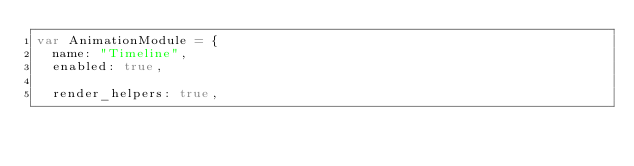<code> <loc_0><loc_0><loc_500><loc_500><_JavaScript_>var AnimationModule = {
	name: "Timeline",
	enabled: true,

	render_helpers: true,</code> 